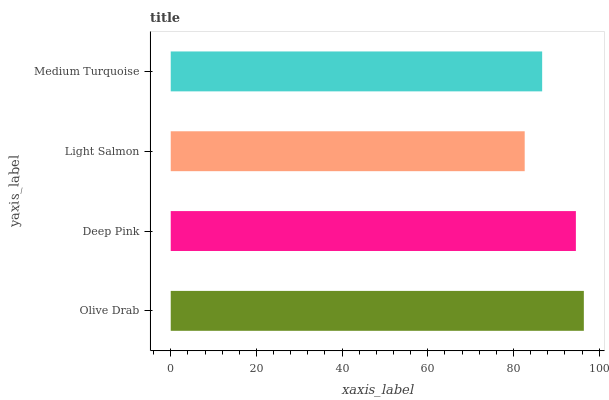Is Light Salmon the minimum?
Answer yes or no. Yes. Is Olive Drab the maximum?
Answer yes or no. Yes. Is Deep Pink the minimum?
Answer yes or no. No. Is Deep Pink the maximum?
Answer yes or no. No. Is Olive Drab greater than Deep Pink?
Answer yes or no. Yes. Is Deep Pink less than Olive Drab?
Answer yes or no. Yes. Is Deep Pink greater than Olive Drab?
Answer yes or no. No. Is Olive Drab less than Deep Pink?
Answer yes or no. No. Is Deep Pink the high median?
Answer yes or no. Yes. Is Medium Turquoise the low median?
Answer yes or no. Yes. Is Medium Turquoise the high median?
Answer yes or no. No. Is Olive Drab the low median?
Answer yes or no. No. 